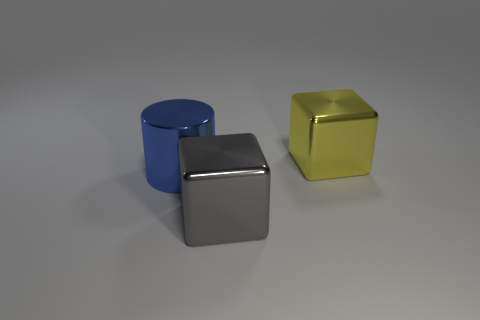Are there more big cylinders that are in front of the blue metal object than large red rubber cylinders?
Your response must be concise. No. What number of things are gray cubes or large blocks that are in front of the blue cylinder?
Make the answer very short. 1. Are there more large shiny things on the left side of the yellow shiny block than blocks on the left side of the big gray cube?
Your response must be concise. Yes. The blue object that is made of the same material as the large gray thing is what shape?
Your response must be concise. Cylinder. Are there any large blue metal cylinders to the right of the large metallic block that is left of the large yellow metal object?
Offer a very short reply. No. How many objects are either purple objects or yellow metallic objects?
Make the answer very short. 1. Is the material of the cube that is behind the metal cylinder the same as the cube that is in front of the big yellow shiny cube?
Provide a succinct answer. Yes. What is the color of the cylinder that is the same material as the big gray block?
Your response must be concise. Blue. How many blue things have the same size as the gray block?
Give a very brief answer. 1. What number of other things are the same color as the big metal cylinder?
Provide a succinct answer. 0. 